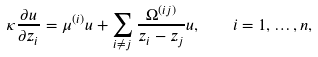Convert formula to latex. <formula><loc_0><loc_0><loc_500><loc_500>\kappa \frac { \partial u } { \partial z _ { i } } = \mu ^ { ( i ) } u + \sum _ { i \ne j } \frac { \Omega ^ { ( i j ) } } { z _ { i } - z _ { j } } u , \quad i = 1 , \dots , n ,</formula> 